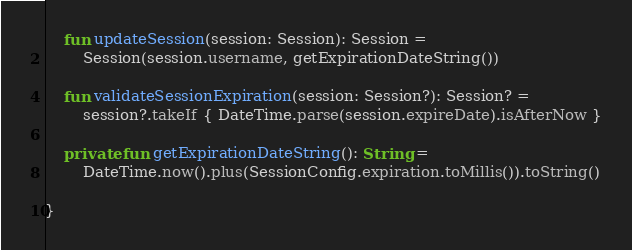Convert code to text. <code><loc_0><loc_0><loc_500><loc_500><_Kotlin_>    fun updateSession(session: Session): Session =
        Session(session.username, getExpirationDateString())

    fun validateSessionExpiration(session: Session?): Session? =
        session?.takeIf { DateTime.parse(session.expireDate).isAfterNow }

    private fun getExpirationDateString(): String =
        DateTime.now().plus(SessionConfig.expiration.toMillis()).toString()

}
</code> 